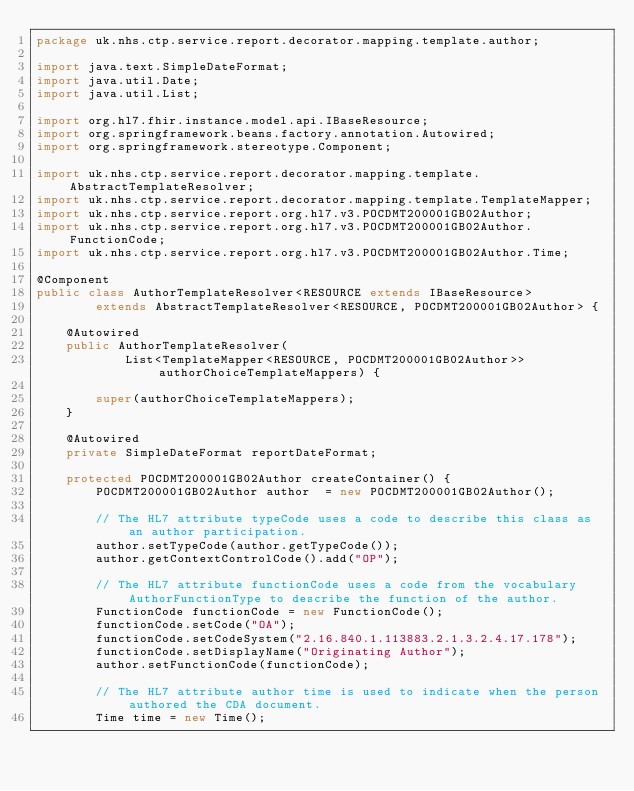<code> <loc_0><loc_0><loc_500><loc_500><_Java_>package uk.nhs.ctp.service.report.decorator.mapping.template.author;

import java.text.SimpleDateFormat;
import java.util.Date;
import java.util.List;

import org.hl7.fhir.instance.model.api.IBaseResource;
import org.springframework.beans.factory.annotation.Autowired;
import org.springframework.stereotype.Component;

import uk.nhs.ctp.service.report.decorator.mapping.template.AbstractTemplateResolver;
import uk.nhs.ctp.service.report.decorator.mapping.template.TemplateMapper;
import uk.nhs.ctp.service.report.org.hl7.v3.POCDMT200001GB02Author;
import uk.nhs.ctp.service.report.org.hl7.v3.POCDMT200001GB02Author.FunctionCode;
import uk.nhs.ctp.service.report.org.hl7.v3.POCDMT200001GB02Author.Time;

@Component
public class AuthorTemplateResolver<RESOURCE extends IBaseResource> 
		extends AbstractTemplateResolver<RESOURCE, POCDMT200001GB02Author> {
	
	@Autowired
	public AuthorTemplateResolver(
			List<TemplateMapper<RESOURCE, POCDMT200001GB02Author>> authorChoiceTemplateMappers) {
		
		super(authorChoiceTemplateMappers);
	}
	
	@Autowired
	private SimpleDateFormat reportDateFormat;
	
	protected POCDMT200001GB02Author createContainer() {
		POCDMT200001GB02Author author  = new POCDMT200001GB02Author();
		
		// The HL7 attribute typeCode uses a code to describe this class as an author participation.
		author.setTypeCode(author.getTypeCode());
		author.getContextControlCode().add("OP");

		// The HL7 attribute functionCode uses a code from the vocabulary AuthorFunctionType to describe the function of the author.
		FunctionCode functionCode = new FunctionCode();
		functionCode.setCode("OA");
		functionCode.setCodeSystem("2.16.840.1.113883.2.1.3.2.4.17.178");
		functionCode.setDisplayName("Originating Author");
		author.setFunctionCode(functionCode);

		// The HL7 attribute author time is used to indicate when the person authored the CDA document.
		Time time = new Time();</code> 